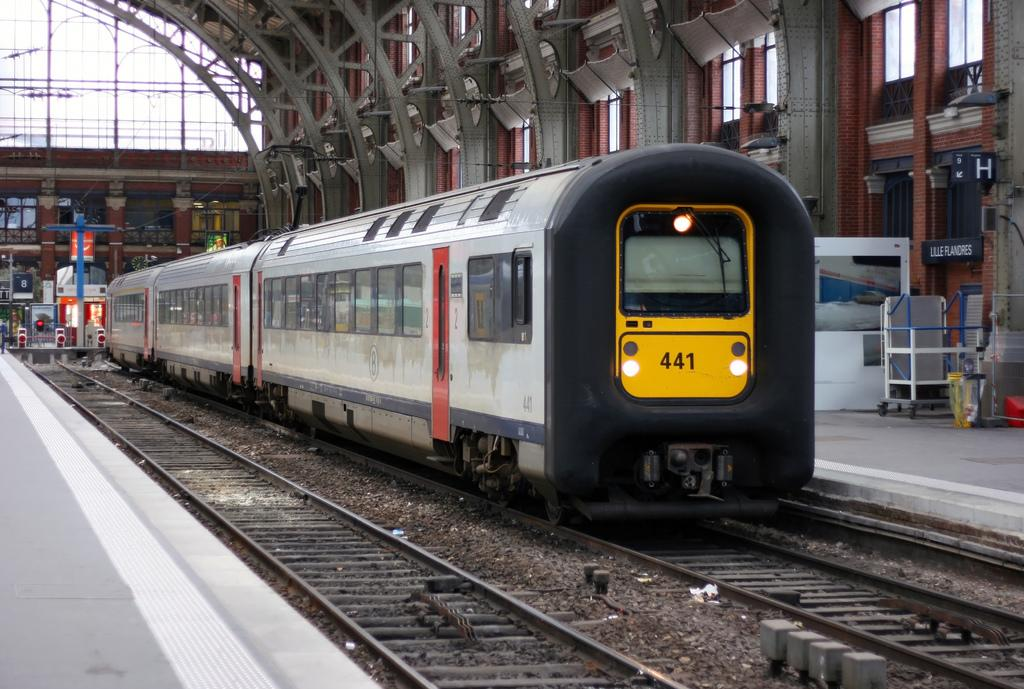What is the main subject of the image? The main subject of the image is a train on the railway track. What can be seen near the train? There are platforms, a trolley, boards, cables, windows, and another railway track visible in the image. Can you describe the platforms in the image? The platforms are structures where passengers can board or disembark from the train. What are the boards used for in the image? The boards in the image might be used for displaying information, such as train schedules or safety instructions. Are there any dinosaurs visible in the image? No, there are no dinosaurs present in the image. Can you see a nest in the image? No, there is no nest visible in the image. 